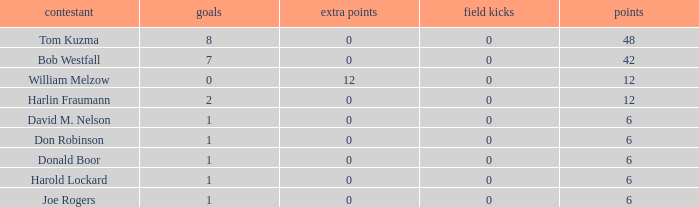List the grades for donald boor. 6.0. 